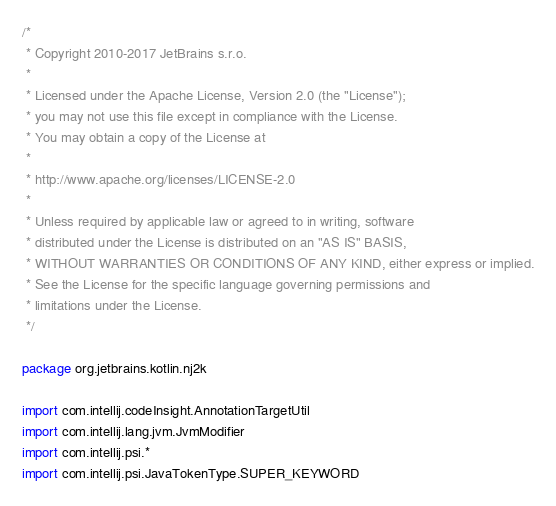Convert code to text. <code><loc_0><loc_0><loc_500><loc_500><_Kotlin_>/*
 * Copyright 2010-2017 JetBrains s.r.o.
 *
 * Licensed under the Apache License, Version 2.0 (the "License");
 * you may not use this file except in compliance with the License.
 * You may obtain a copy of the License at
 *
 * http://www.apache.org/licenses/LICENSE-2.0
 *
 * Unless required by applicable law or agreed to in writing, software
 * distributed under the License is distributed on an "AS IS" BASIS,
 * WITHOUT WARRANTIES OR CONDITIONS OF ANY KIND, either express or implied.
 * See the License for the specific language governing permissions and
 * limitations under the License.
 */

package org.jetbrains.kotlin.nj2k

import com.intellij.codeInsight.AnnotationTargetUtil
import com.intellij.lang.jvm.JvmModifier
import com.intellij.psi.*
import com.intellij.psi.JavaTokenType.SUPER_KEYWORD</code> 